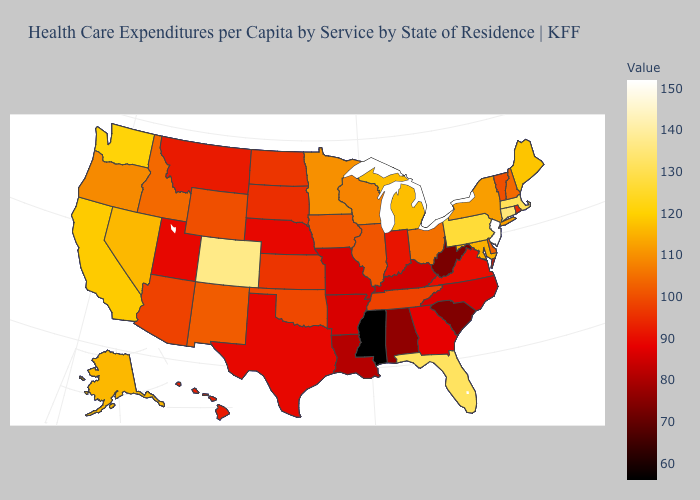Does the map have missing data?
Be succinct. No. Does Rhode Island have the lowest value in the Northeast?
Keep it brief. Yes. Among the states that border South Carolina , which have the highest value?
Answer briefly. Georgia. Among the states that border Kansas , which have the lowest value?
Concise answer only. Missouri. Among the states that border Minnesota , does Wisconsin have the lowest value?
Quick response, please. No. Which states have the highest value in the USA?
Be succinct. New Jersey. 